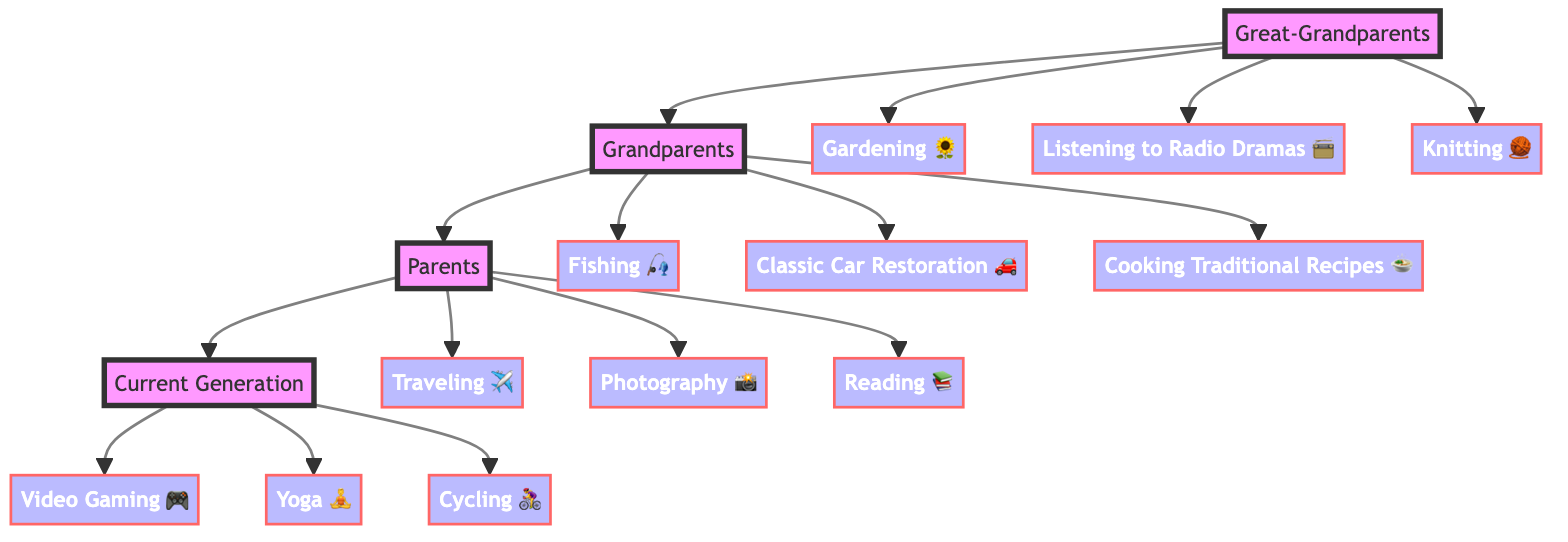What hobbies do the Great-Grandparents have? The diagram lists three hobbies under the Great-Grandparents node: Gardening, Listening to Radio Dramas, and Knitting. These can be found directly beneath the Great-Grandparents node.
Answer: Gardening, Listening to Radio Dramas, Knitting How many hobbies do the Grandparents have? The Grandparents node has three hobbies connected to it: Fishing, Classic Car Restoration, and Cooking Traditional Recipes. Count these connections to find the total.
Answer: 3 Which hobby is associated with the Current Generation? The Current Generation has three hobbies: Video Gaming, Yoga, and Cycling, identified directly under the Current Generation node in the diagram.
Answer: Video Gaming, Yoga, Cycling What is the last generation listed in the family tree? The flow of connections leads from Great-Grandparents to Grandparents, then to Parents, and finally to the Current Generation. The Current Generation is the last node at the end of these connections.
Answer: Current Generation Is there a hobby related to cooking in the Grandparents' interests? In the Grandparents section, one of the hobbies is Cooking Traditional Recipes, which confirms that cooking is indeed associated with this generation's interests.
Answer: Yes Which generation shows an interest in traveling? Looking through the diagram, the Parents segment indicates an interest in Traveling, directly listed as one of their hobbies.
Answer: Parents Which two generations have an interest in yarn-related activities? Only the Great-Grandparents have Craft-related hobbies, specifically Knitting, while the diagram does not include any yarn-related activities for the other generations, indicating only the Great-Grandparents hold this interest.
Answer: Great-Grandparents How are the Parents connected to the Current Generation? The Parents node connects directly to the Current Generation node, illustrating the familial relationship from Parents to their children in the Current Generation.
Answer: Parents to Current Generation Name one hobby that evolved over generations. Analyzing the hobbies, Traveling is a recurring interest that reflects an evolution from the more localized hobbies of earlier generations to a broader exploration seen in the Parents and Current Generation.
Answer: Traveling 